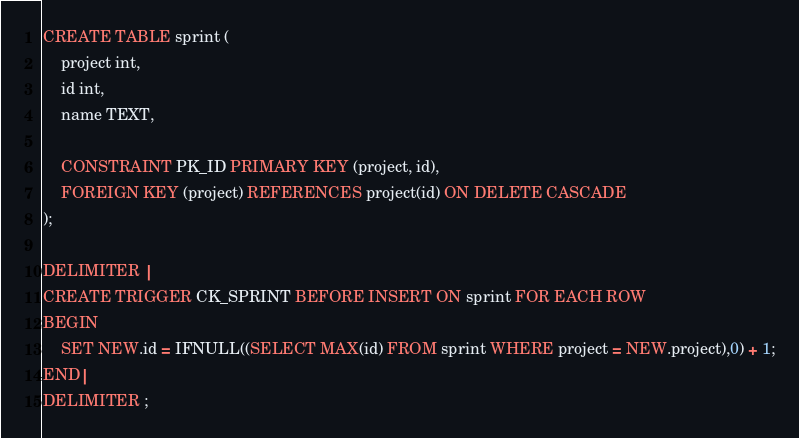Convert code to text. <code><loc_0><loc_0><loc_500><loc_500><_SQL_>CREATE TABLE sprint (
    project int,
    id int,
    name TEXT,

    CONSTRAINT PK_ID PRIMARY KEY (project, id),
    FOREIGN KEY (project) REFERENCES project(id) ON DELETE CASCADE
);

DELIMITER |
CREATE TRIGGER CK_SPRINT BEFORE INSERT ON sprint FOR EACH ROW 
BEGIN
    SET NEW.id = IFNULL((SELECT MAX(id) FROM sprint WHERE project = NEW.project),0) + 1;
END| 
DELIMITER ;</code> 